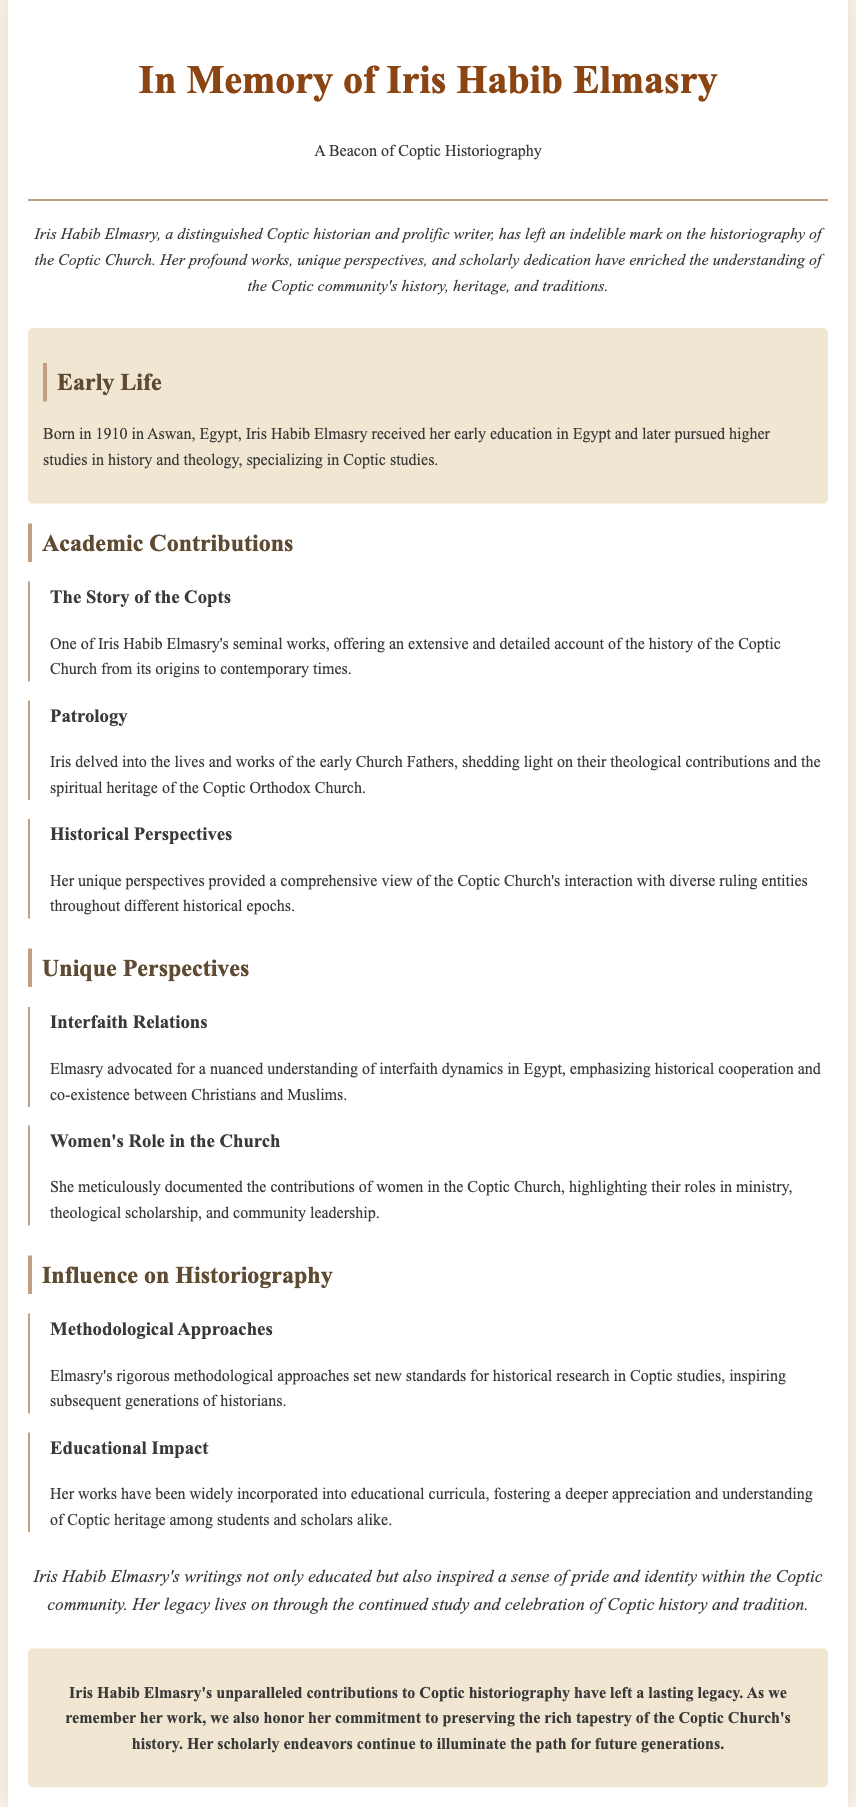What year was Iris Habib Elmasry born? The document states that she was born in 1910.
Answer: 1910 What is one of Iris Habib Elmasry's seminal works? The document specifically mentions "The Story of the Copts" as a seminal work.
Answer: The Story of the Copts Which topic did Iris Habib Elmasry emphasize in her unique perspectives? The document highlights her focus on interfaith relations and women's roles in the Church as key topics.
Answer: Interfaith relations What was the effect of Elmasry's writings on the Coptic community? The document mentions that her writings inspired a sense of pride and identity within the Coptic community.
Answer: Pride and identity What type of methodological approach did Iris Habib Elmasry set? The document describes her methodological approaches as rigorous, setting new standards.
Answer: Rigorous Which city in Egypt was Iris Habib Elmasry born? The document states that she was born in Aswan, Egypt.
Answer: Aswan What major impact did her works have on education? According to the document, her works have been widely incorporated into educational curricula.
Answer: Educational curricula What overarching theme is highlighted in Iris Habib Elmasry's legacy? The document emphasizes her commitment to preserving the history of the Coptic Church as a key theme.
Answer: Preserving history 